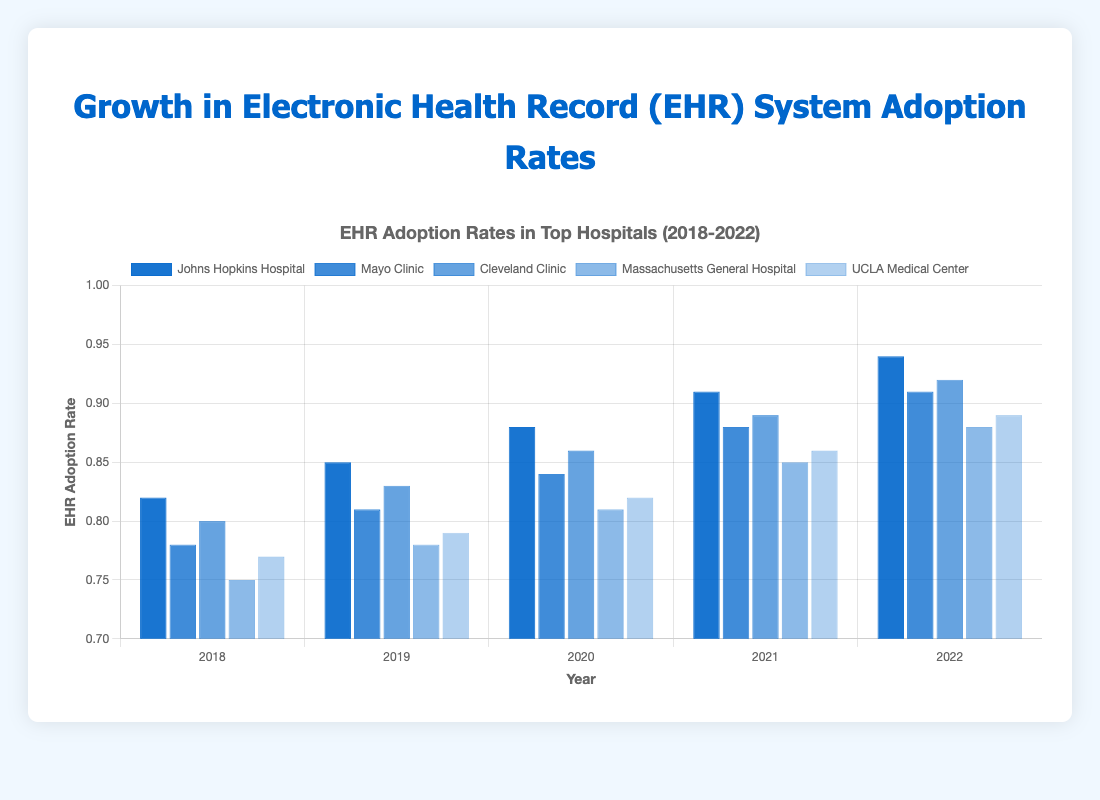Which hospital had the highest EHR adoption rate in 2022? Look at the bars for the year 2022 and identify which hospital has the tallest bar. Johns Hopkins Hospital has the tallest bar for 2022.
Answer: Johns Hopkins Hospital What was the EHR adoption rate of Mayo Clinic in 2020 and how much did it increase from 2019? First, find Mayo Clinic’s adoption rate in 2020 (0.84) and 2019 (0.81). Then subtract 0.81 from 0.84.
Answer: 0.03 Which hospital showed the most significant growth in EHR adoption rate from 2018 to 2022? Calculate the differences for each hospital by subtracting the 2018 values from the 2022 values. The differences are Johns Hopkins Hospital (0.94 - 0.82 = 0.12), Mayo Clinic (0.91 - 0.78 = 0.13), Cleveland Clinic (0.92 - 0.80 = 0.12), Massachusetts General Hospital (0.88 - 0.75 = 0.13), UCLA Medical Center (0.89 - 0.77 = 0.12). Mayo Clinic and Massachusetts General Hospital both have the largest growth of 0.13.
Answer: Mayo Clinic, Massachusetts General Hospital What is the average EHR adoption rate for Cleveland Clinic over the five years? Sum the data points for Cleveland Clinic (0.80, 0.83, 0.86, 0.89, 0.92) to get 4.30, then divide by 5.
Answer: 0.86 Which year did Massachusetts General Hospital experience the largest increase in EHR adoption rate compared to the previous year? Calculate the yearly differences: 2019-2018 (0.78 - 0.75 = 0.03), 2020-2019 (0.81 - 0.78 = 0.03), 2021-2020 (0.85 - 0.81 = 0.04), 2022-2021 (0.88 - 0.85 = 0.03). The largest increase occurred from 2020 to 2021.
Answer: 2021 How does UCLA Medical Center's EHR adoption rate in 2022 compare to its rate in 2018? Subtract the 2018 rate (0.77) from the 2022 rate (0.89).
Answer: 0.12 Identify the year when Johns Hopkins Hospital's EHR adoption rate increased by 0.03 compared to the previous year. Compare the differences year by year: 2019-2018 (0.85 - 0.82 = 0.03), 2020-2019 (0.88 - 0.85 = 0.03). Both 2019 and 2020 saw an increase of 0.03.
Answer: 2019, 2020 Which hospital had the most consistent growth in EHR adoption rates over the years? Observe the visual growth patterns or calculate per-year differences for each hospital. Johns Hopkins Hospital consistently increased by approximately 0.03 each year.
Answer: Johns Hopkins Hospital 